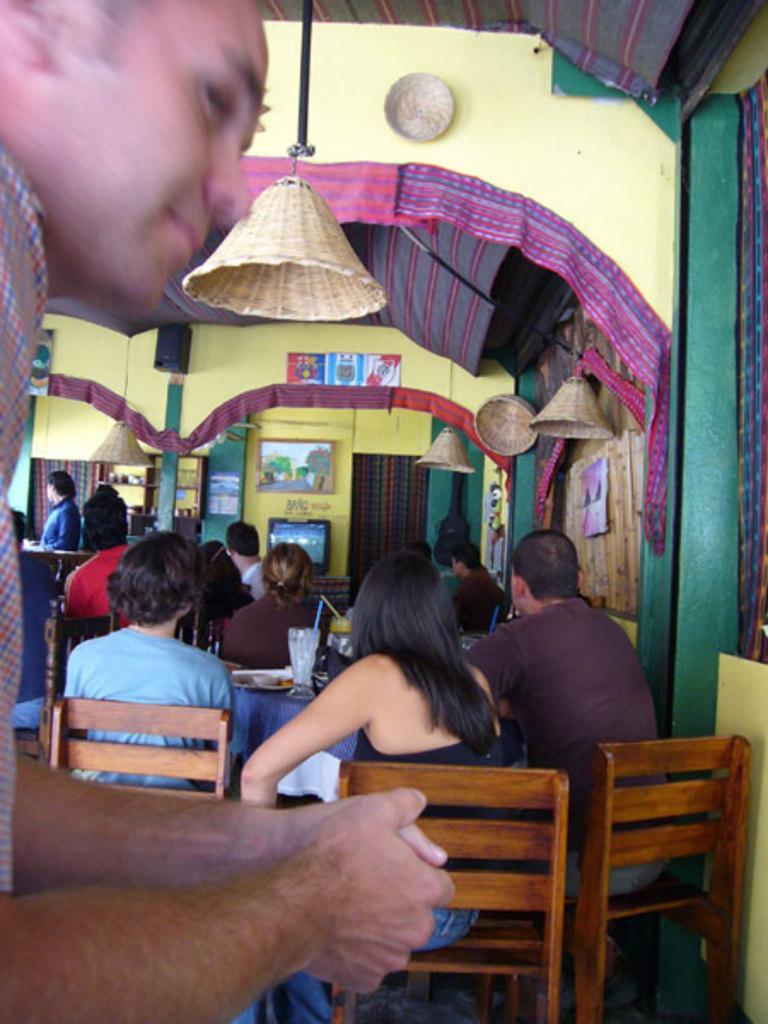Please provide a concise description of this image. In the image there is man sat in front. In background there is a woman and another man sat on chair in front of table. its seems to be of hotel. There are curtains and cloth over to the edges and, on top a light hanging on. 